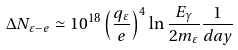Convert formula to latex. <formula><loc_0><loc_0><loc_500><loc_500>\Delta N _ { \varepsilon - e } \simeq 1 0 ^ { 1 8 } \left ( \frac { q _ { \varepsilon } } { e } \right ) ^ { 4 } \ln \frac { E _ { \gamma } } { 2 m _ { \varepsilon } } \frac { 1 } { d a y }</formula> 